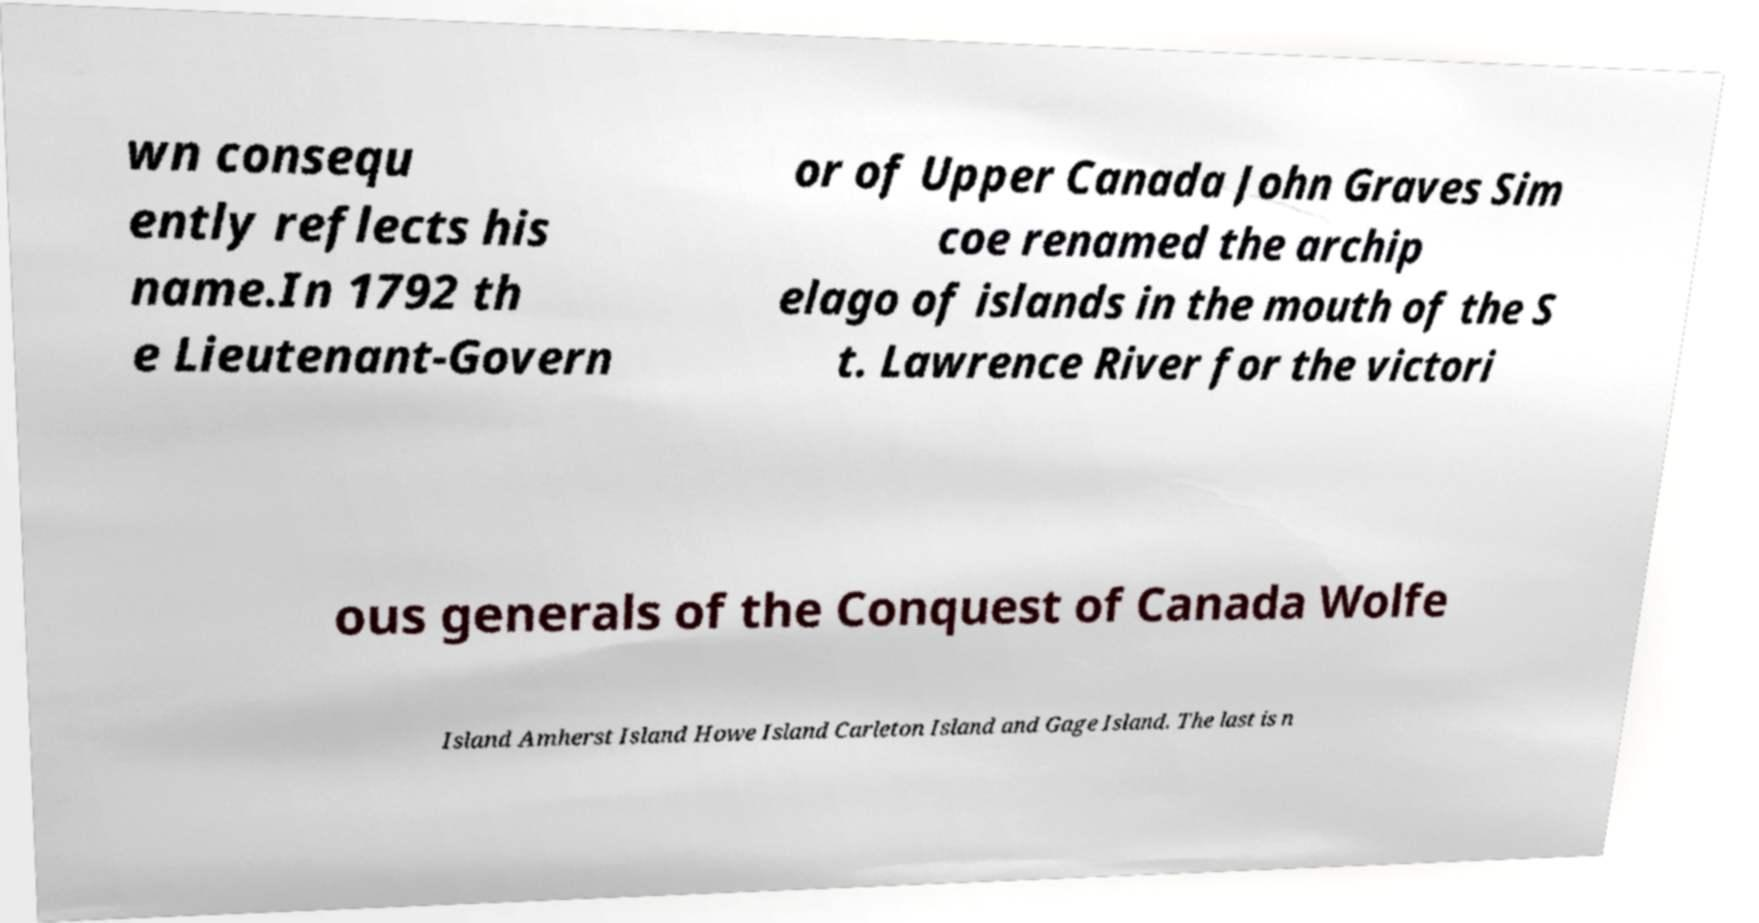For documentation purposes, I need the text within this image transcribed. Could you provide that? wn consequ ently reflects his name.In 1792 th e Lieutenant-Govern or of Upper Canada John Graves Sim coe renamed the archip elago of islands in the mouth of the S t. Lawrence River for the victori ous generals of the Conquest of Canada Wolfe Island Amherst Island Howe Island Carleton Island and Gage Island. The last is n 